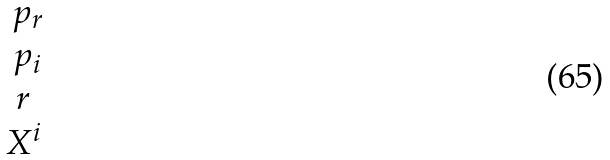<formula> <loc_0><loc_0><loc_500><loc_500>\begin{matrix} \ p _ { r } \\ \ p _ { i } \\ r \\ X ^ { i } \\ \end{matrix}</formula> 